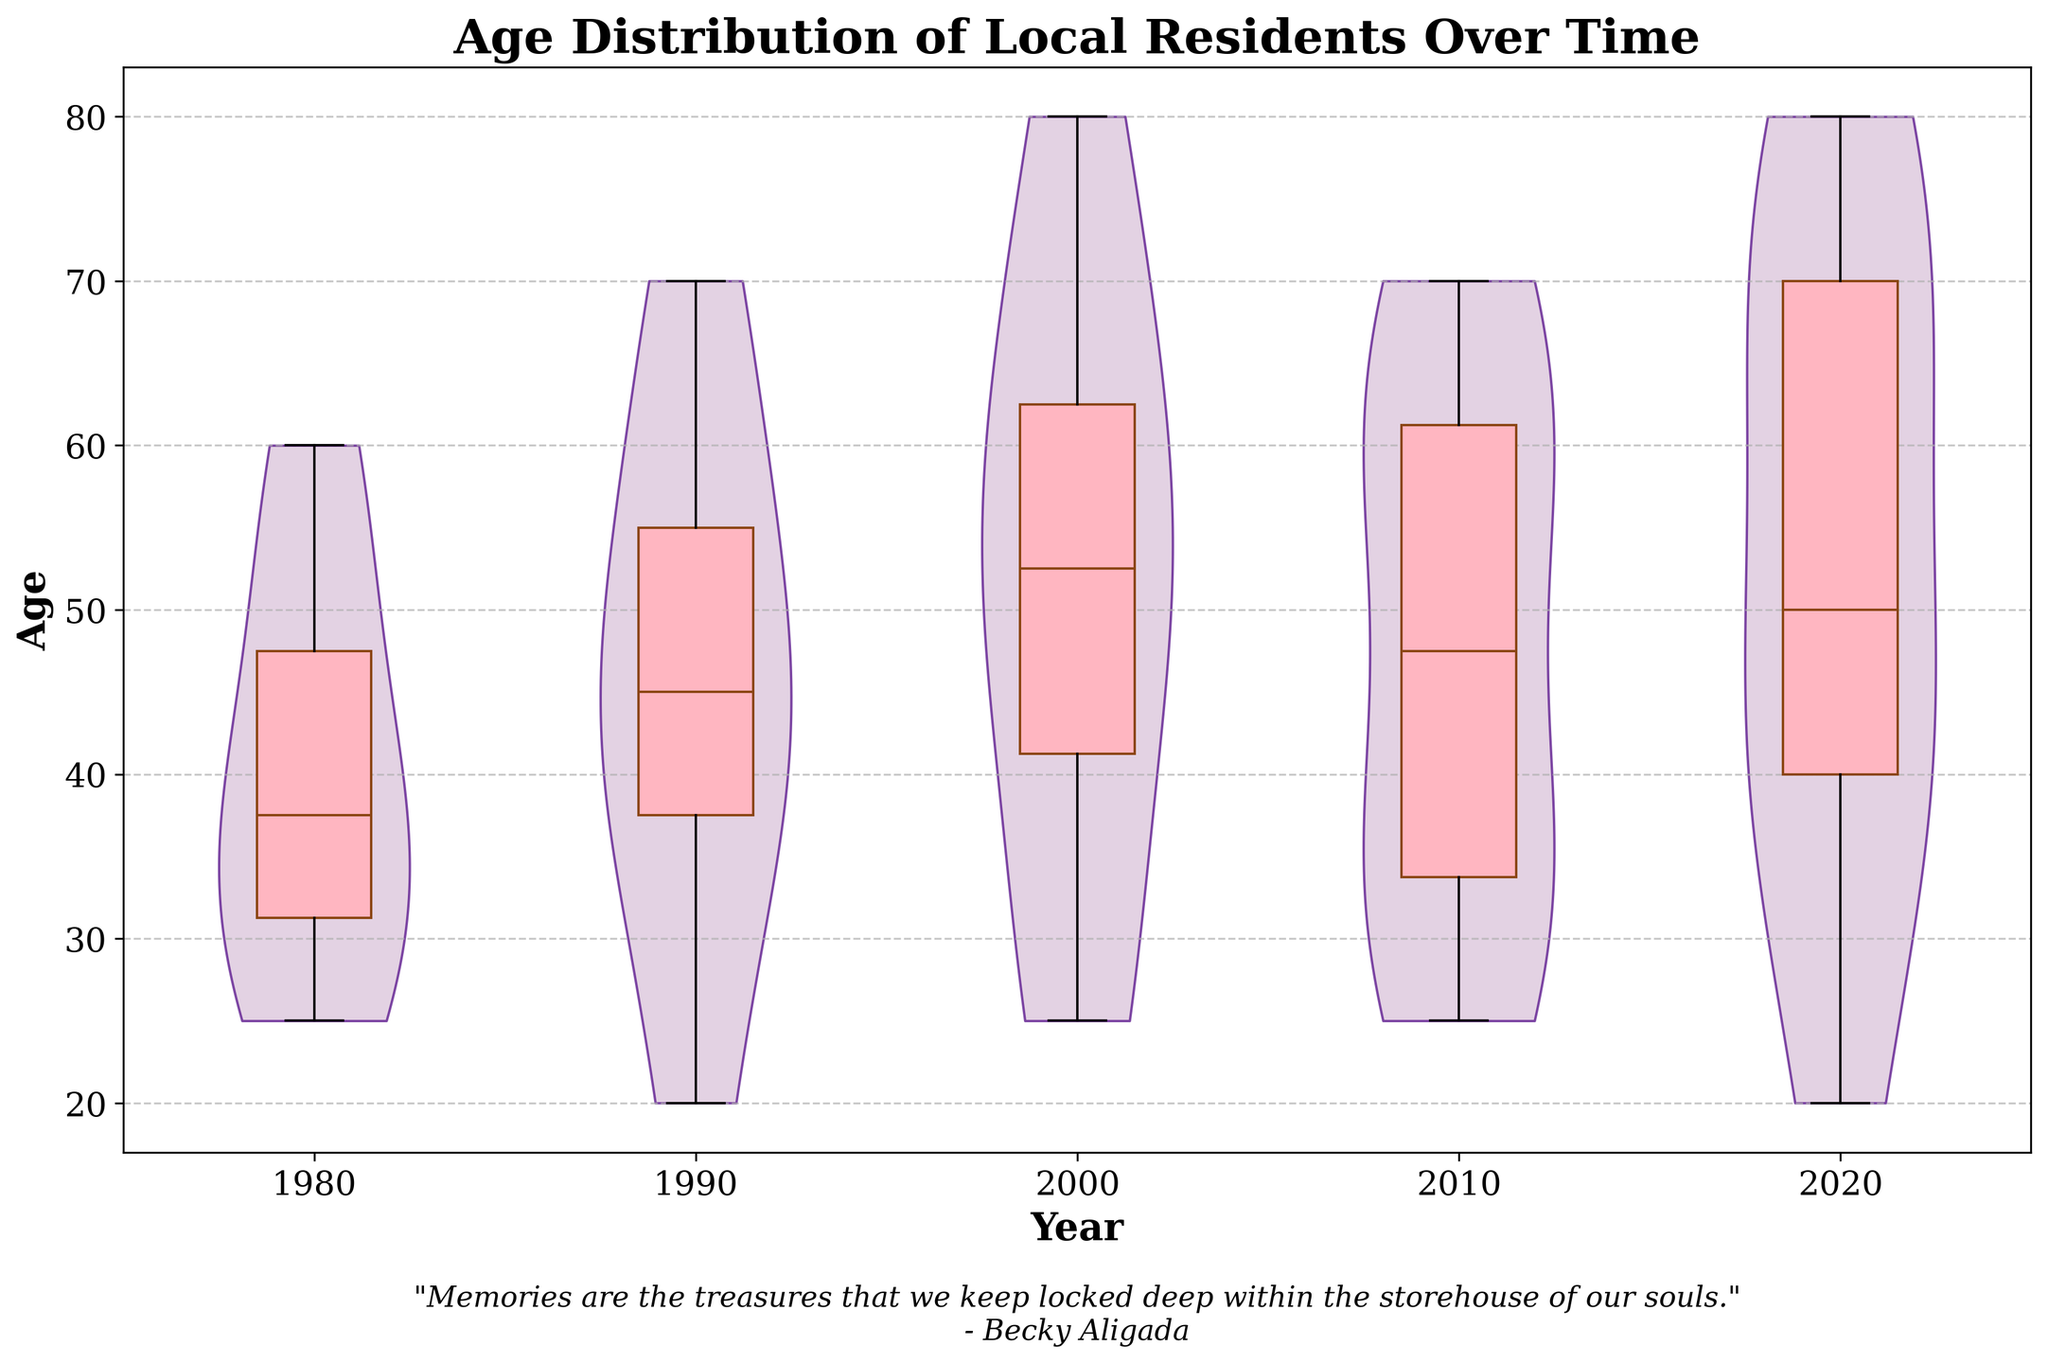What is the title of the figure? The title of the figure can be found at the top of the chart. It states, "Age Distribution of Local Residents Over Time."
Answer: Age Distribution of Local Residents Over Time What is the range of ages in 2020? The range can be found by looking at the spread of the violin plot and box plot for the year 2020. From the plot, the ages range from about 20 to 80 years old.
Answer: 20 to 80 How many years are displayed on the x-axis? The x-axis has labels for each year shown in the plot. By counting these labels, we see that the years 1980, 1990, 2000, 2010, and 2020 are displayed.
Answer: 5 What can you say about the median age in 2000? The median age is represented by the horizontal line in the center of each box plot. For the year 2000, this line appears around the age of 55.
Answer: 55 Which year has the smallest interquartile range (IQR) for ages? The IQR is represented by the width of the box in the box plot. By comparing the widths across years, the year with the smallest box (indicating the smallest IQR) is 2010.
Answer: 2010 How did the age distribution change between 1980 and 2020? Comparing the violin plots, the distribution has widened significantly from 1980 to 2020. In 1980, the ages are more concentrated in a mid-range, while in 2020, the ages are more spread out, indicating a wider range of ages in the population.
Answer: More spread out Which year shows the highest concentration of young individuals? The highest concentration of young individuals can be seen where the violin plot is widest at the lower age range. By examining the plots, the widest spread at the lower ages is in 1980.
Answer: 1980 What is the difference in the median ages between 2010 and 2020? The median is represented by the line within each box. For 2010, the median age is around 40, and for 2020, it's around 45. Subtracting these, the difference is 5 years.
Answer: 5 years In which year is the age distribution most symmetric? A symmetric distribution will have a violin plot and box plot that look evenly spread about the center. The year 1980 exhibits the most symmetric age distribution.
Answer: 1980 What might the upper "whisker" indicate in the 2020 box plot? The upper whisker of a box plot typically represents the upper quartile range or the highest data points that are not considered outliers. In 2020, it indicates the highest ages being around 80 years.
Answer: Upper quartile range or highest data points 